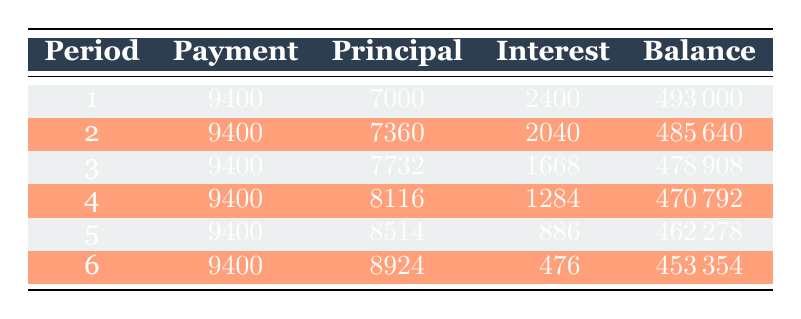What is the total payment made in the first period? The payment made in the first period is explicitly listed in the table as 9400.
Answer: 9400 How much was the principal payment in the second period? The principal payment for the second period can be found directly in the table under the Principal column for period 2, which is 7360.
Answer: 7360 Is the interest payment in the fifth period greater than that in the first period? The interest payment in the fifth period is 886, while in the first period it is 2400. Since 886 is less than 2400, the statement is false.
Answer: No What is the total interest payment made during the first three periods combined? To find the total interest payment for the first three periods, we add the interest payments of each period: 2400 + 2040 + 1668 = 6108.
Answer: 6108 What is the remaining balance after the sixth period? The remaining balance after the sixth period is clearly noted in the table as 453354.
Answer: 453354 Which period shows the highest principal payment, and what is that amount? By examining the Principal column for each period, the maximum principal payment appears in period 6 at 8924.
Answer: Period 6, 8924 How much total payment will have been made after six periods? The total payment for six periods can be calculated by multiplying the payment amount per period (9400) by the number of periods (6): 9400 * 6 = 56400.
Answer: 56400 Is the average payment per period equal to 9400? The average payment per period is calculated by dividing the total payment (9400 * 6) by 6, which equals 9400. This confirms the average payment is indeed 9400.
Answer: Yes In which period does the remaining balance drop below 470000? By checking the Remaining Balance column, we find that the first period having a balance under 470000 occurs at period 4, where the remaining balance is 470792. Period 5 then drops to 462278, which is below 470000.
Answer: Period 5 